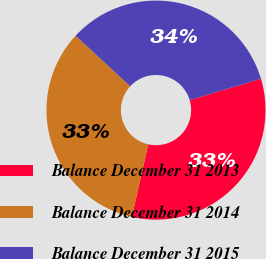Convert chart to OTSL. <chart><loc_0><loc_0><loc_500><loc_500><pie_chart><fcel>Balance December 31 2013<fcel>Balance December 31 2014<fcel>Balance December 31 2015<nl><fcel>33.16%<fcel>33.33%<fcel>33.51%<nl></chart> 